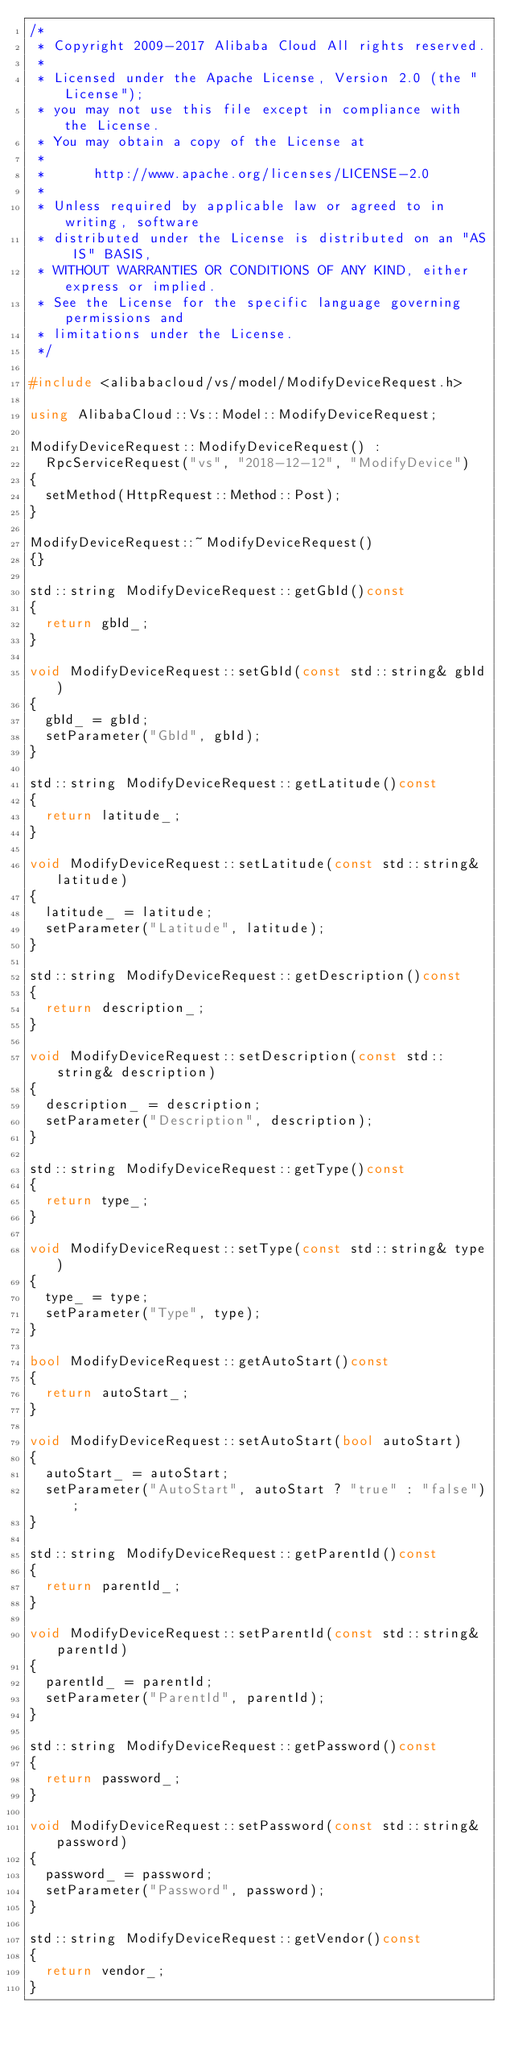Convert code to text. <code><loc_0><loc_0><loc_500><loc_500><_C++_>/*
 * Copyright 2009-2017 Alibaba Cloud All rights reserved.
 * 
 * Licensed under the Apache License, Version 2.0 (the "License");
 * you may not use this file except in compliance with the License.
 * You may obtain a copy of the License at
 * 
 *      http://www.apache.org/licenses/LICENSE-2.0
 * 
 * Unless required by applicable law or agreed to in writing, software
 * distributed under the License is distributed on an "AS IS" BASIS,
 * WITHOUT WARRANTIES OR CONDITIONS OF ANY KIND, either express or implied.
 * See the License for the specific language governing permissions and
 * limitations under the License.
 */

#include <alibabacloud/vs/model/ModifyDeviceRequest.h>

using AlibabaCloud::Vs::Model::ModifyDeviceRequest;

ModifyDeviceRequest::ModifyDeviceRequest() :
	RpcServiceRequest("vs", "2018-12-12", "ModifyDevice")
{
	setMethod(HttpRequest::Method::Post);
}

ModifyDeviceRequest::~ModifyDeviceRequest()
{}

std::string ModifyDeviceRequest::getGbId()const
{
	return gbId_;
}

void ModifyDeviceRequest::setGbId(const std::string& gbId)
{
	gbId_ = gbId;
	setParameter("GbId", gbId);
}

std::string ModifyDeviceRequest::getLatitude()const
{
	return latitude_;
}

void ModifyDeviceRequest::setLatitude(const std::string& latitude)
{
	latitude_ = latitude;
	setParameter("Latitude", latitude);
}

std::string ModifyDeviceRequest::getDescription()const
{
	return description_;
}

void ModifyDeviceRequest::setDescription(const std::string& description)
{
	description_ = description;
	setParameter("Description", description);
}

std::string ModifyDeviceRequest::getType()const
{
	return type_;
}

void ModifyDeviceRequest::setType(const std::string& type)
{
	type_ = type;
	setParameter("Type", type);
}

bool ModifyDeviceRequest::getAutoStart()const
{
	return autoStart_;
}

void ModifyDeviceRequest::setAutoStart(bool autoStart)
{
	autoStart_ = autoStart;
	setParameter("AutoStart", autoStart ? "true" : "false");
}

std::string ModifyDeviceRequest::getParentId()const
{
	return parentId_;
}

void ModifyDeviceRequest::setParentId(const std::string& parentId)
{
	parentId_ = parentId;
	setParameter("ParentId", parentId);
}

std::string ModifyDeviceRequest::getPassword()const
{
	return password_;
}

void ModifyDeviceRequest::setPassword(const std::string& password)
{
	password_ = password;
	setParameter("Password", password);
}

std::string ModifyDeviceRequest::getVendor()const
{
	return vendor_;
}
</code> 